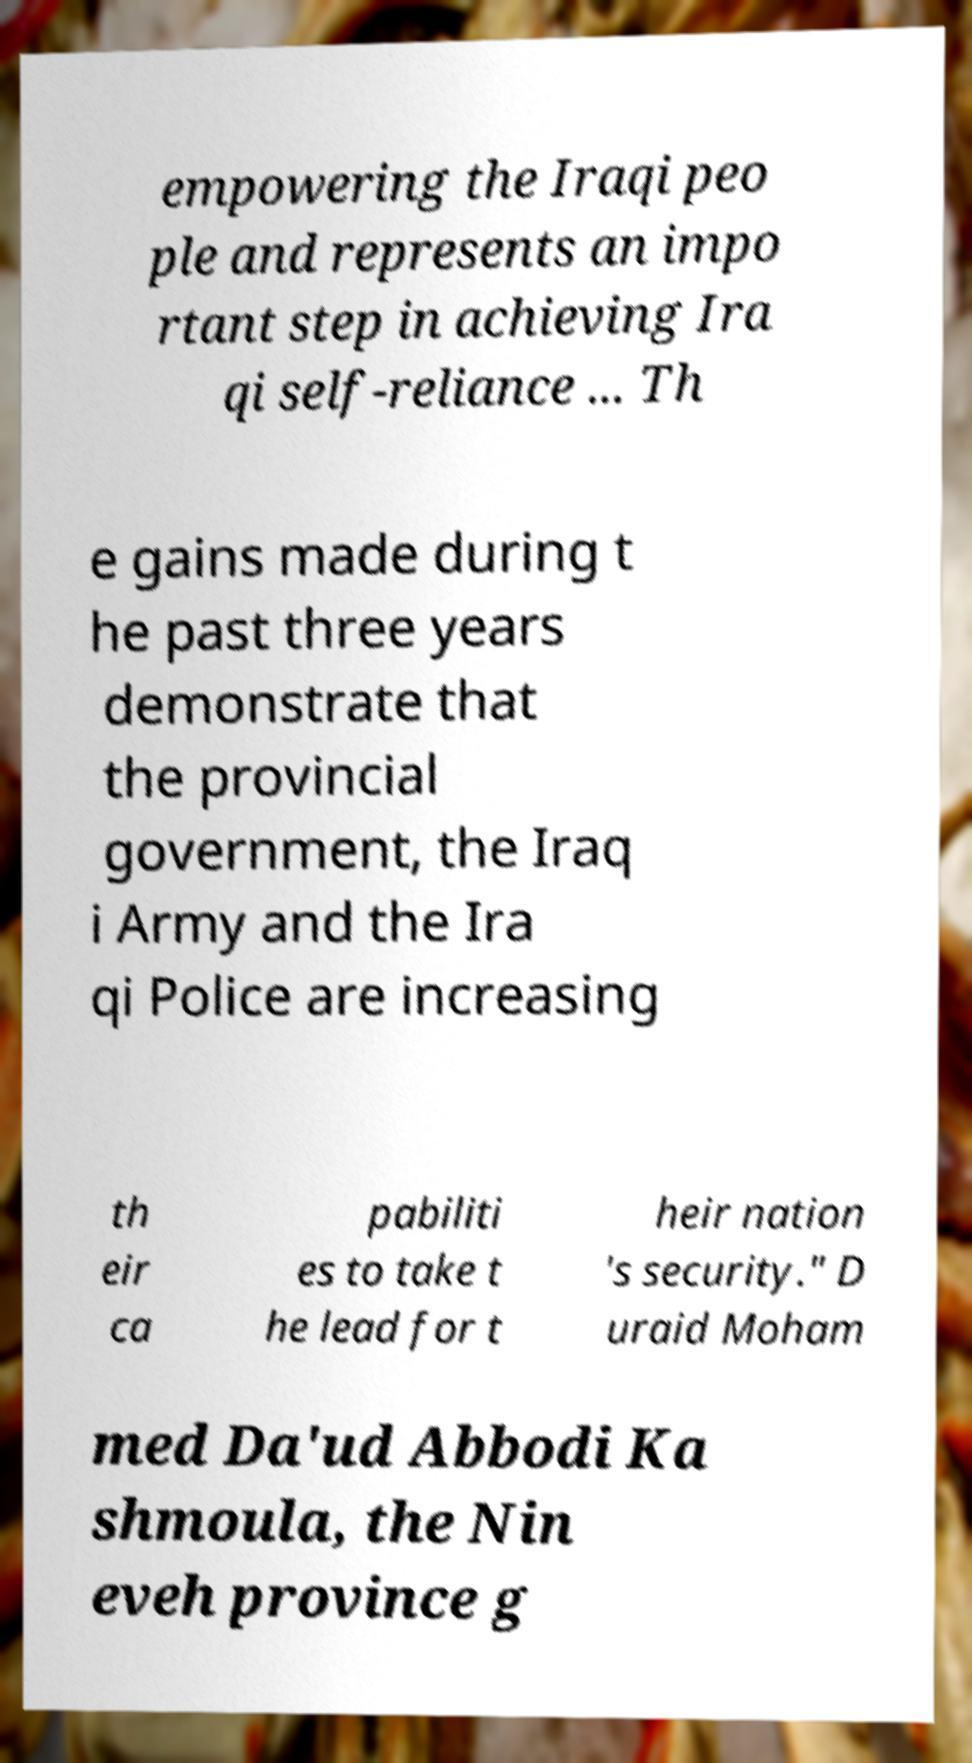What messages or text are displayed in this image? I need them in a readable, typed format. empowering the Iraqi peo ple and represents an impo rtant step in achieving Ira qi self-reliance ... Th e gains made during t he past three years demonstrate that the provincial government, the Iraq i Army and the Ira qi Police are increasing th eir ca pabiliti es to take t he lead for t heir nation 's security." D uraid Moham med Da'ud Abbodi Ka shmoula, the Nin eveh province g 